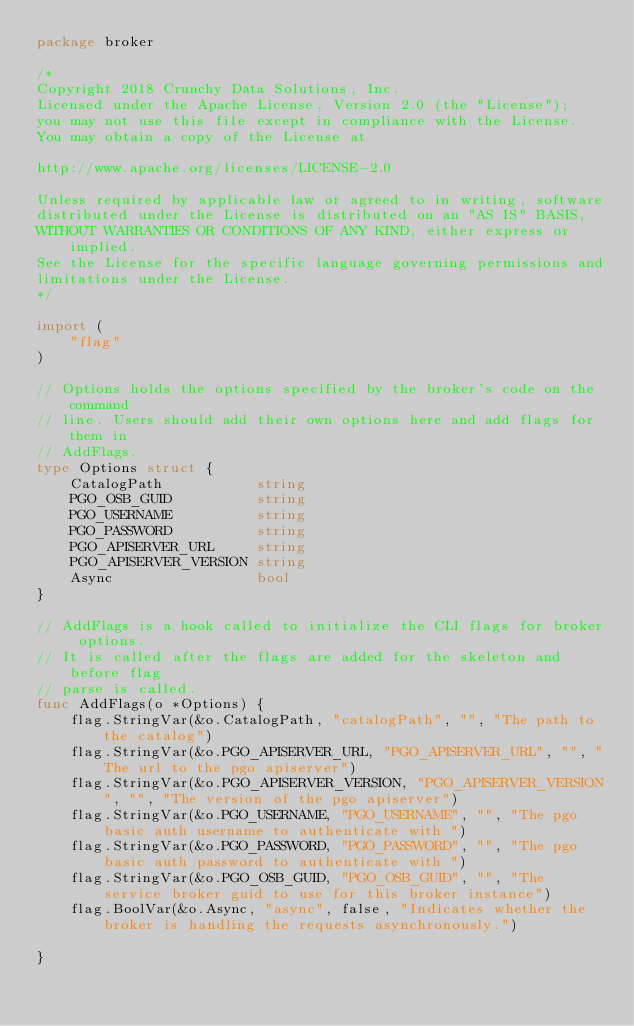Convert code to text. <code><loc_0><loc_0><loc_500><loc_500><_Go_>package broker

/*
Copyright 2018 Crunchy Data Solutions, Inc.
Licensed under the Apache License, Version 2.0 (the "License");
you may not use this file except in compliance with the License.
You may obtain a copy of the License at

http://www.apache.org/licenses/LICENSE-2.0

Unless required by applicable law or agreed to in writing, software
distributed under the License is distributed on an "AS IS" BASIS,
WITHOUT WARRANTIES OR CONDITIONS OF ANY KIND, either express or implied.
See the License for the specific language governing permissions and
limitations under the License.
*/

import (
	"flag"
)

// Options holds the options specified by the broker's code on the command
// line. Users should add their own options here and add flags for them in
// AddFlags.
type Options struct {
	CatalogPath           string
	PGO_OSB_GUID          string
	PGO_USERNAME          string
	PGO_PASSWORD          string
	PGO_APISERVER_URL     string
	PGO_APISERVER_VERSION string
	Async                 bool
}

// AddFlags is a hook called to initialize the CLI flags for broker options.
// It is called after the flags are added for the skeleton and before flag
// parse is called.
func AddFlags(o *Options) {
	flag.StringVar(&o.CatalogPath, "catalogPath", "", "The path to the catalog")
	flag.StringVar(&o.PGO_APISERVER_URL, "PGO_APISERVER_URL", "", "The url to the pgo apiserver")
	flag.StringVar(&o.PGO_APISERVER_VERSION, "PGO_APISERVER_VERSION", "", "The version of the pgo apiserver")
	flag.StringVar(&o.PGO_USERNAME, "PGO_USERNAME", "", "The pgo basic auth username to authenticate with ")
	flag.StringVar(&o.PGO_PASSWORD, "PGO_PASSWORD", "", "The pgo basic auth password to authenticate with ")
	flag.StringVar(&o.PGO_OSB_GUID, "PGO_OSB_GUID", "", "The service broker guid to use for this broker instance")
	flag.BoolVar(&o.Async, "async", false, "Indicates whether the broker is handling the requests asynchronously.")

}
</code> 